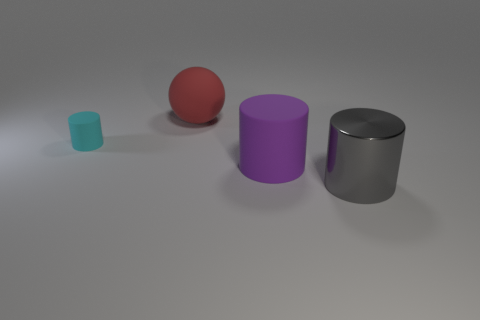How many metallic things are either red balls or big green blocks?
Provide a short and direct response. 0. How many purple objects are big rubber cylinders or small matte cylinders?
Give a very brief answer. 1. Is the color of the large cylinder behind the big gray thing the same as the large ball?
Your answer should be very brief. No. Do the big purple object and the cyan object have the same material?
Your response must be concise. Yes. Is the number of big objects that are behind the purple rubber object the same as the number of big red spheres that are in front of the red rubber ball?
Give a very brief answer. No. There is a big purple object that is the same shape as the cyan matte thing; what is its material?
Make the answer very short. Rubber. There is a rubber thing that is on the left side of the large thing that is on the left side of the rubber object on the right side of the large red rubber object; what is its shape?
Keep it short and to the point. Cylinder. Are there more spheres right of the big red matte object than big blue shiny cylinders?
Offer a terse response. No. There is a big rubber thing that is in front of the large red object; does it have the same shape as the gray object?
Offer a very short reply. Yes. What is the material of the big cylinder that is behind the big gray metal thing?
Provide a short and direct response. Rubber. 